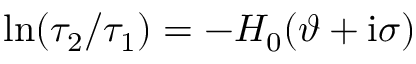<formula> <loc_0><loc_0><loc_500><loc_500>\ln ( \tau _ { 2 } / \tau _ { 1 } ) = - H _ { 0 } ( \vartheta + i \sigma )</formula> 